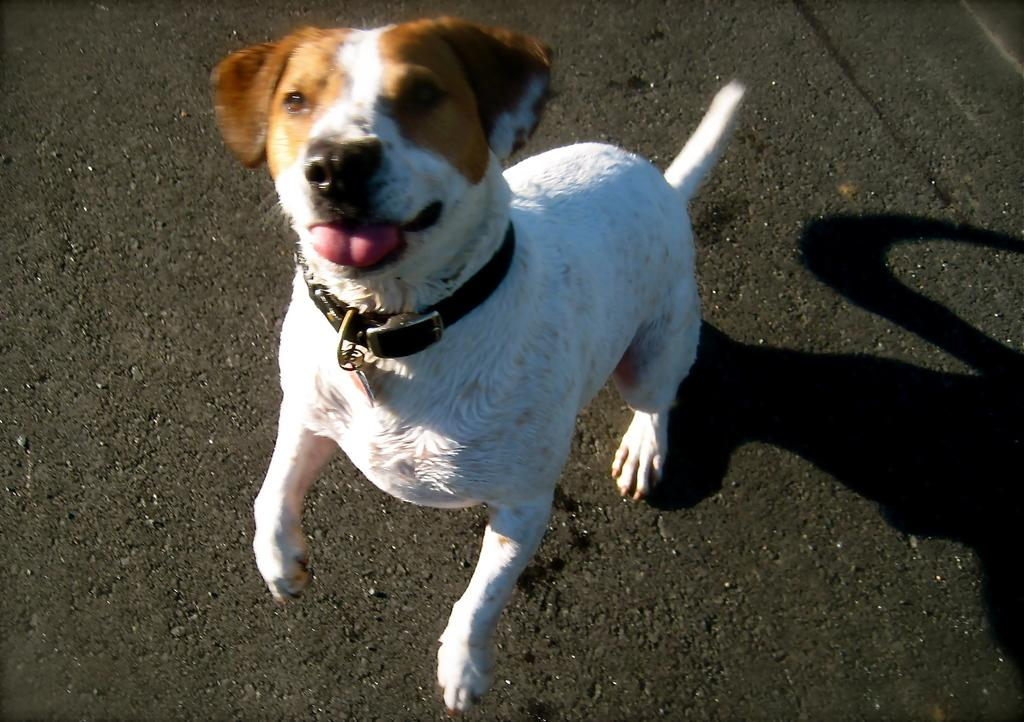What type of animal is in the image? There is a dog in the image. Can you describe the dog's appearance? The dog is white and brown in color. Where is the dog located in the image? The dog is on the road. What is the dog wearing in the image? The dog is wearing a black color belt. How many branches can be seen in the image? There are no branches visible in the image; it features a dog on the road. What type of observation is the dog making in the image? The image does not depict the dog making any specific observation, so it cannot be determined. 